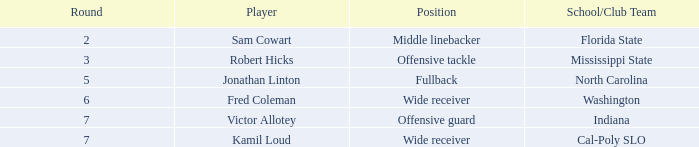Which Round has a School/Club Team of indiana, and a Pick smaller than 198? None. 